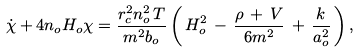<formula> <loc_0><loc_0><loc_500><loc_500>\dot { \chi } + 4 n _ { o } H _ { o } \chi = \frac { r _ { c } ^ { 2 } n _ { o } ^ { 2 } \, T } { m ^ { 2 } b _ { o } } \left ( \, H _ { o } ^ { 2 } \, - \, \frac { \rho \, + \, V } { 6 m ^ { 2 } } \, + \, \frac { k } { a _ { o } ^ { 2 } } \, \right ) ,</formula> 